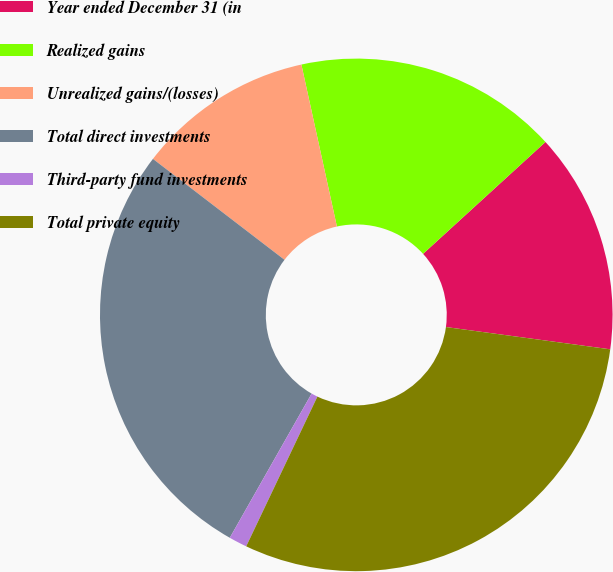<chart> <loc_0><loc_0><loc_500><loc_500><pie_chart><fcel>Year ended December 31 (in<fcel>Realized gains<fcel>Unrealized gains/(losses)<fcel>Total direct investments<fcel>Third-party fund investments<fcel>Total private equity<nl><fcel>13.93%<fcel>16.65%<fcel>11.15%<fcel>27.2%<fcel>1.15%<fcel>29.92%<nl></chart> 